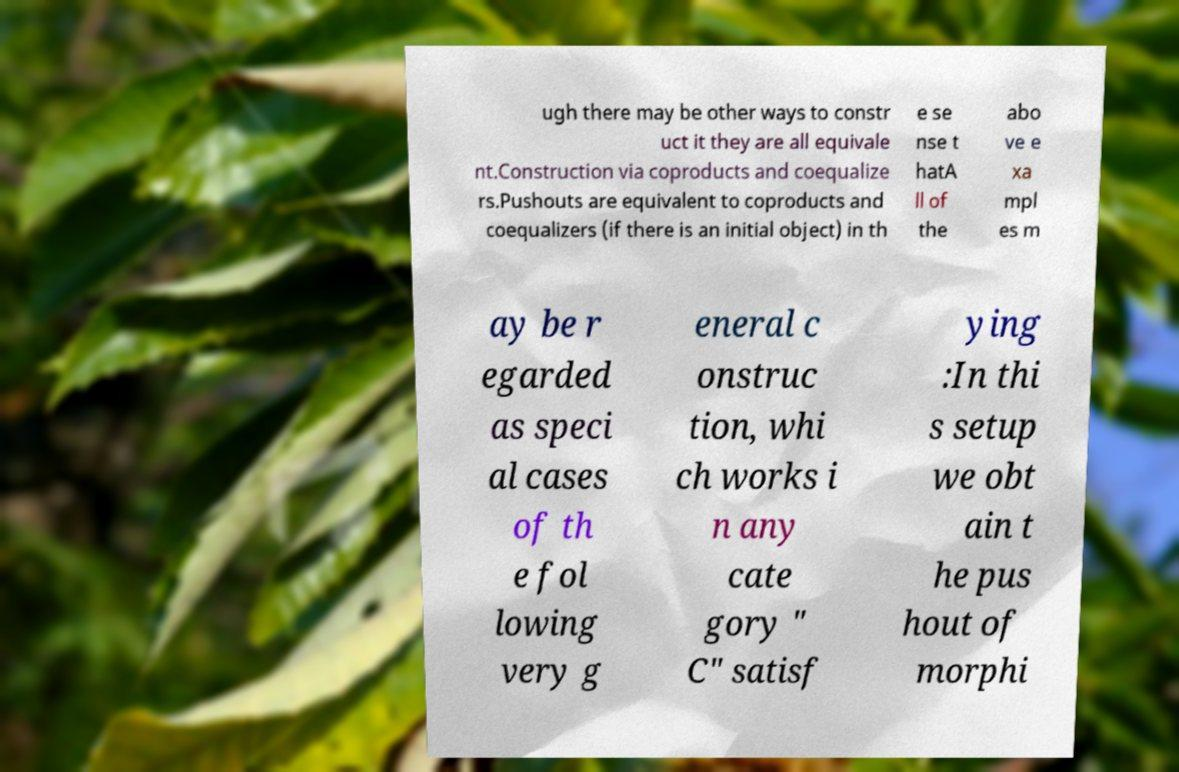Please identify and transcribe the text found in this image. ugh there may be other ways to constr uct it they are all equivale nt.Construction via coproducts and coequalize rs.Pushouts are equivalent to coproducts and coequalizers (if there is an initial object) in th e se nse t hatA ll of the abo ve e xa mpl es m ay be r egarded as speci al cases of th e fol lowing very g eneral c onstruc tion, whi ch works i n any cate gory " C" satisf ying :In thi s setup we obt ain t he pus hout of morphi 